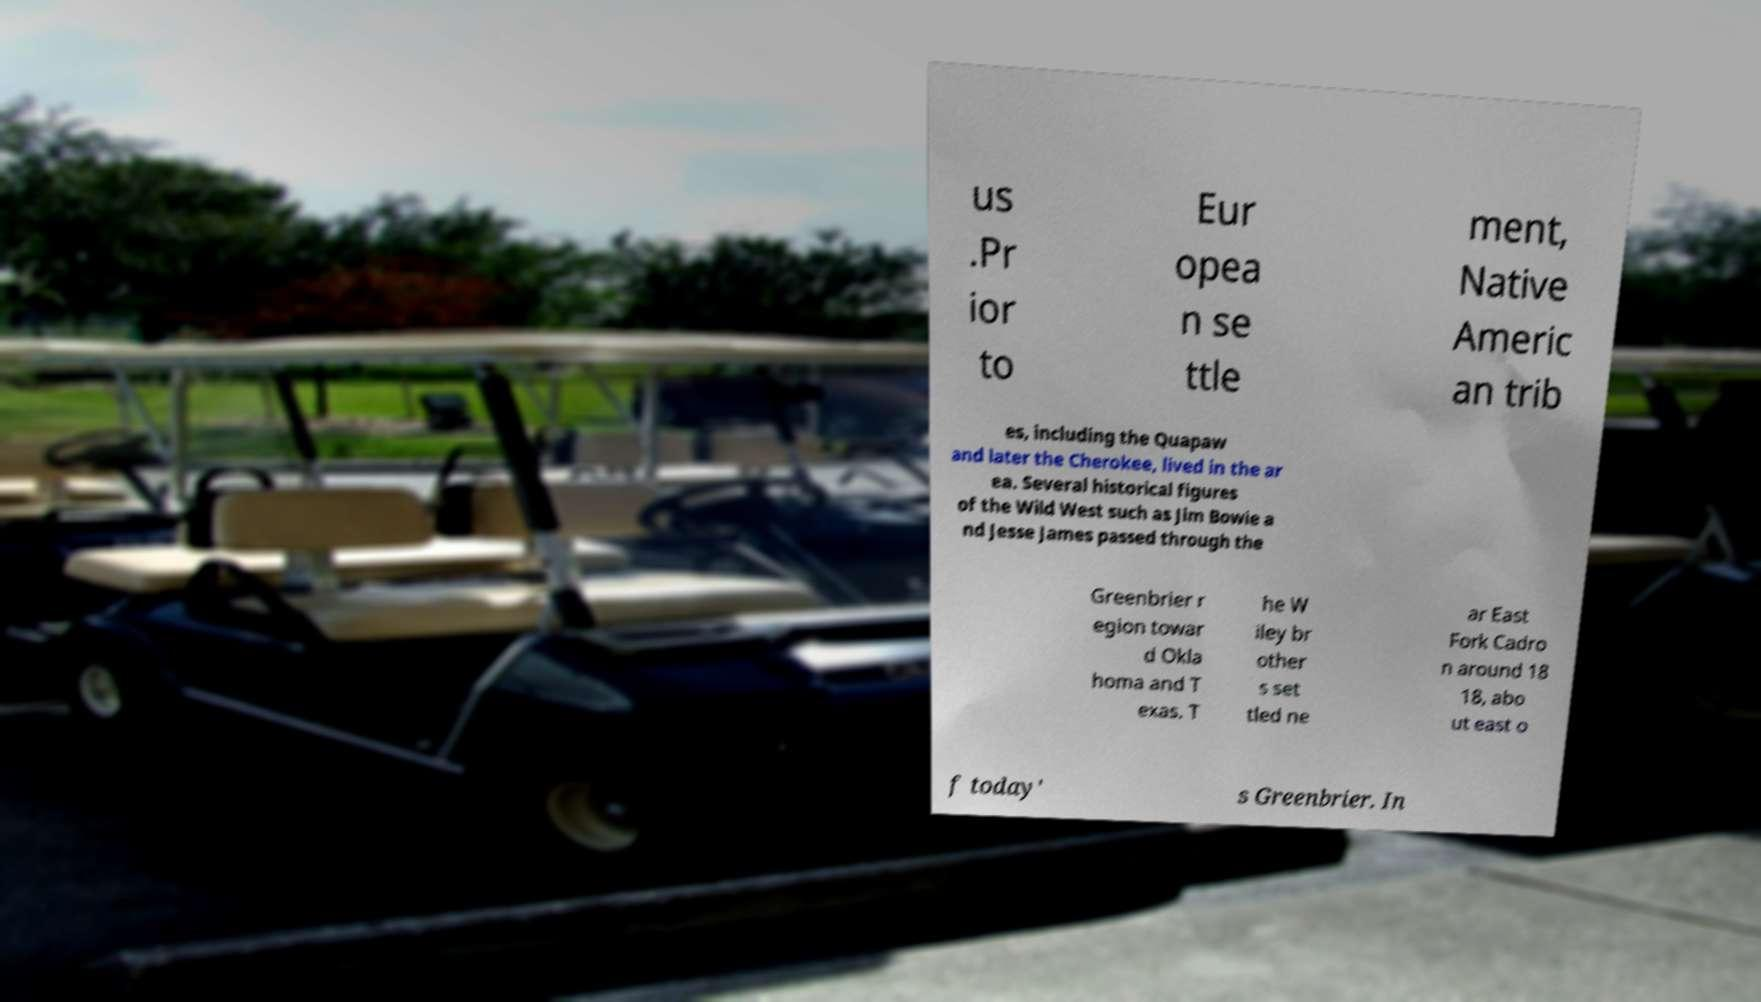Could you extract and type out the text from this image? us .Pr ior to Eur opea n se ttle ment, Native Americ an trib es, including the Quapaw and later the Cherokee, lived in the ar ea. Several historical figures of the Wild West such as Jim Bowie a nd Jesse James passed through the Greenbrier r egion towar d Okla homa and T exas. T he W iley br other s set tled ne ar East Fork Cadro n around 18 18, abo ut east o f today' s Greenbrier. In 